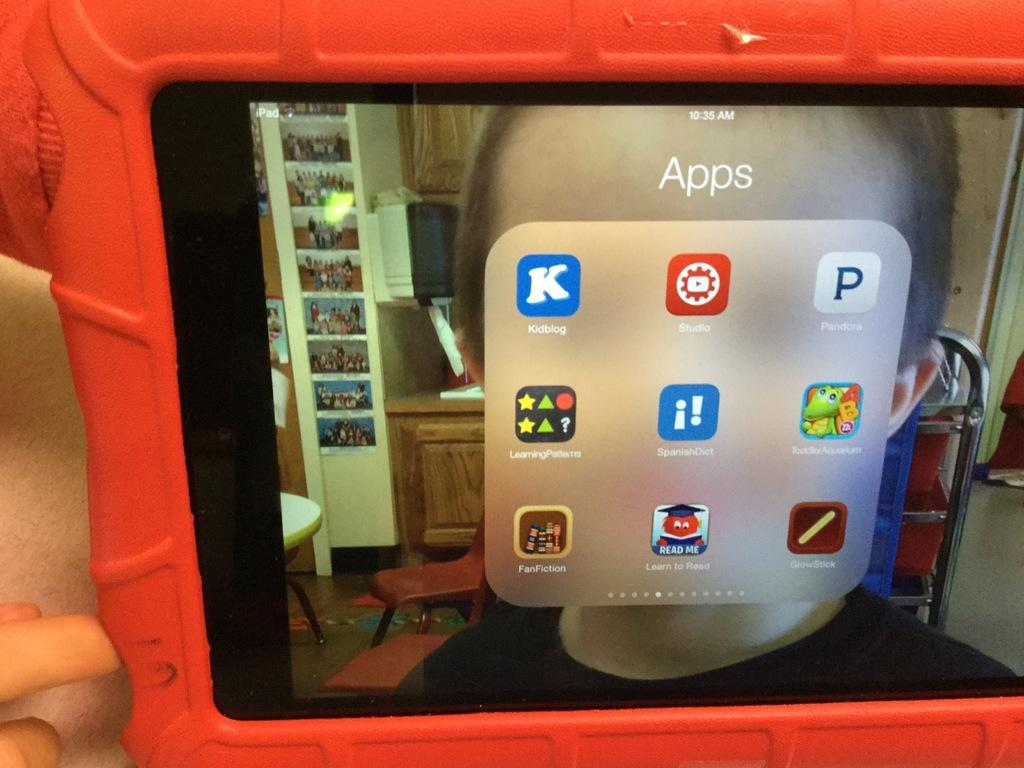<image>
Give a short and clear explanation of the subsequent image. iPAD showing different apps with "Kidblog" being the first. 